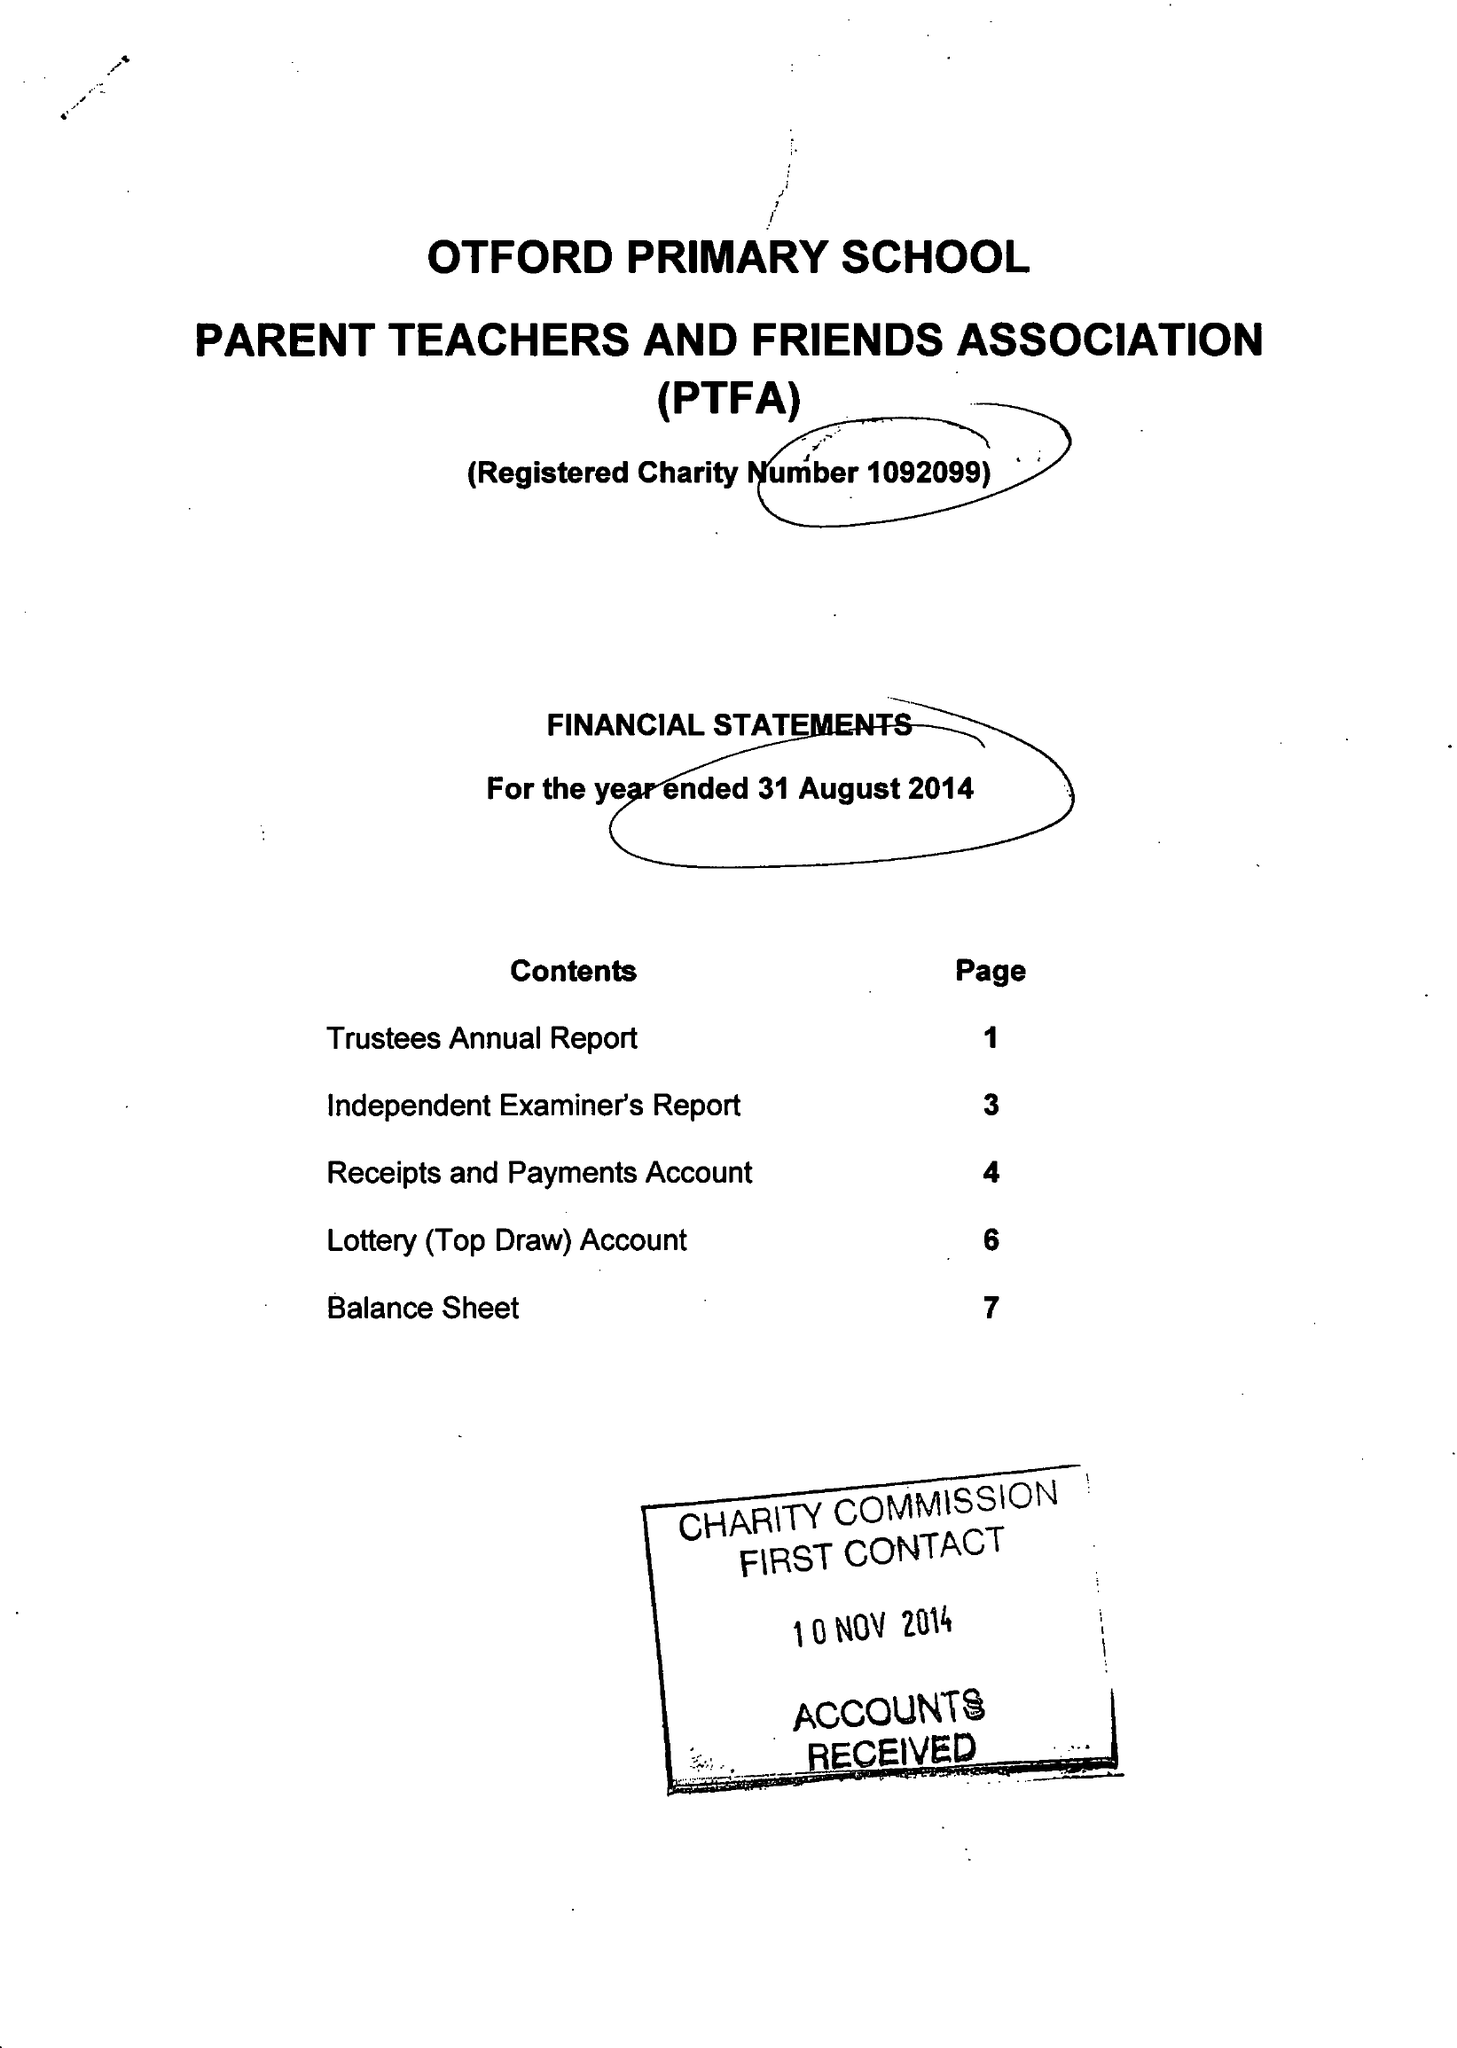What is the value for the address__street_line?
Answer the question using a single word or phrase. HIGH STREET 